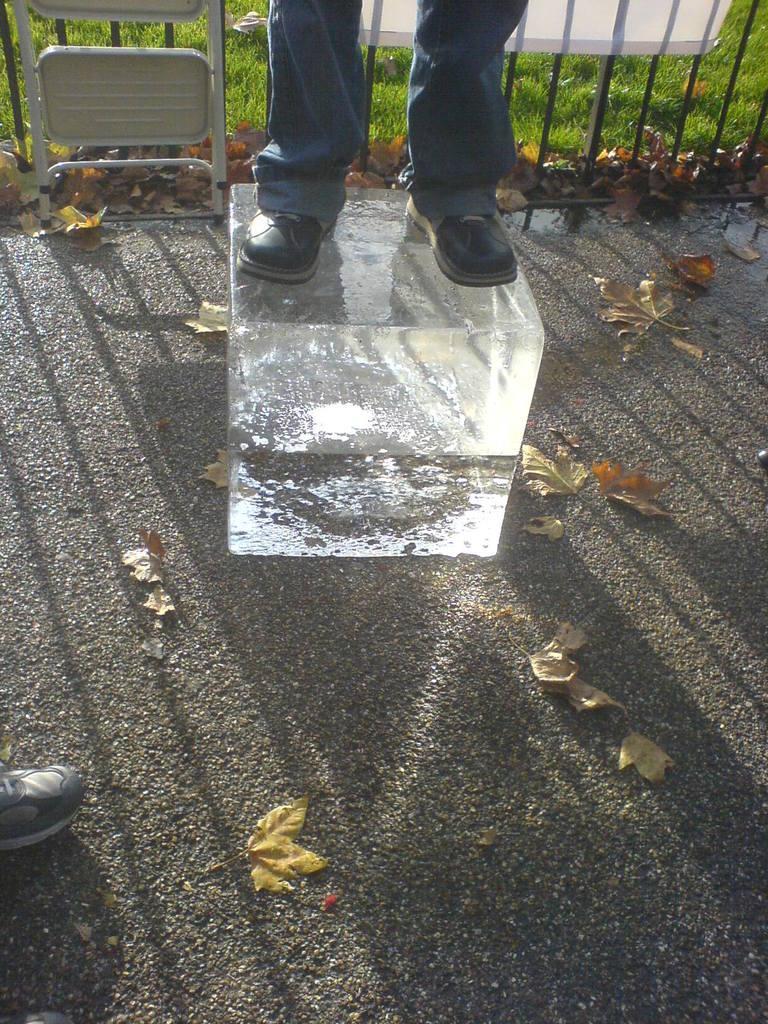Describe this image in one or two sentences. In this picture we can see a person standing on an object. There is another person on the left side. We can see some leaves on the road. Some grass is visible on the ground. There is some fencing from left to right. 